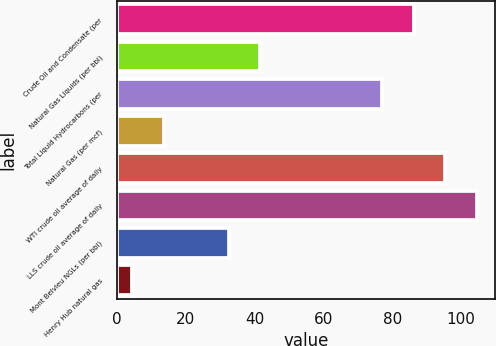Convert chart to OTSL. <chart><loc_0><loc_0><loc_500><loc_500><bar_chart><fcel>Crude Oil and Condensate (per<fcel>Natural Gas Liquids (per bbl)<fcel>Total Liquid Hydrocarbons (per<fcel>Natural Gas (per mcf)<fcel>WTI crude oil average of daily<fcel>LLS crude oil average of daily<fcel>Mont Belvieu NGLs (per bbl)<fcel>Henry Hub natural gas<nl><fcel>86.24<fcel>41.74<fcel>77.02<fcel>13.64<fcel>95.46<fcel>104.68<fcel>32.52<fcel>4.42<nl></chart> 